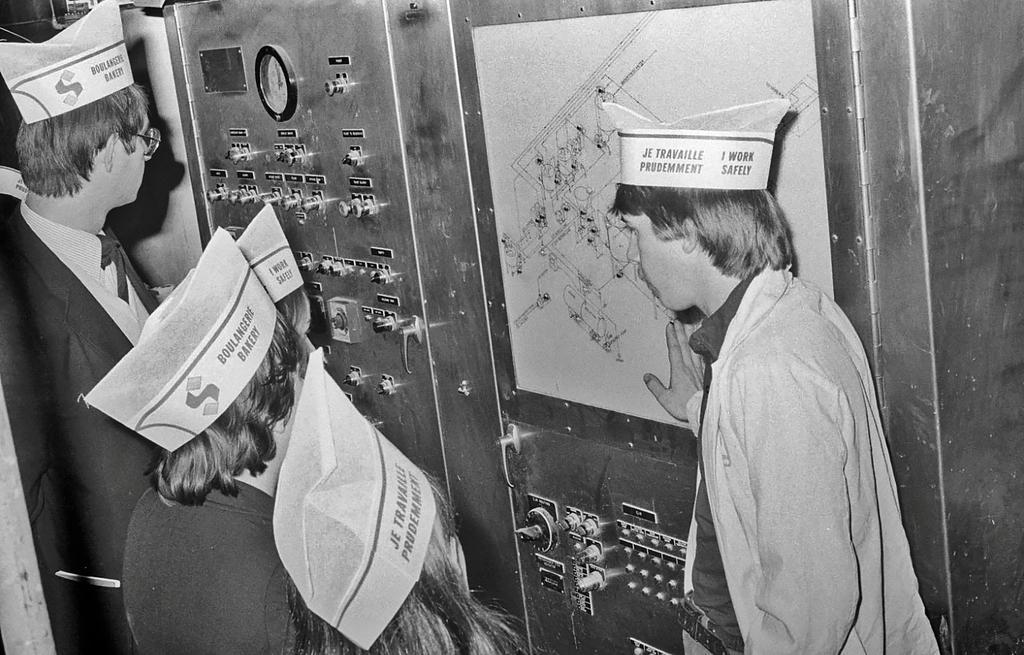Could you give a brief overview of what you see in this image? It is a black and white image there are few people standing in front of a machine and a person is explaining the map to the people. 